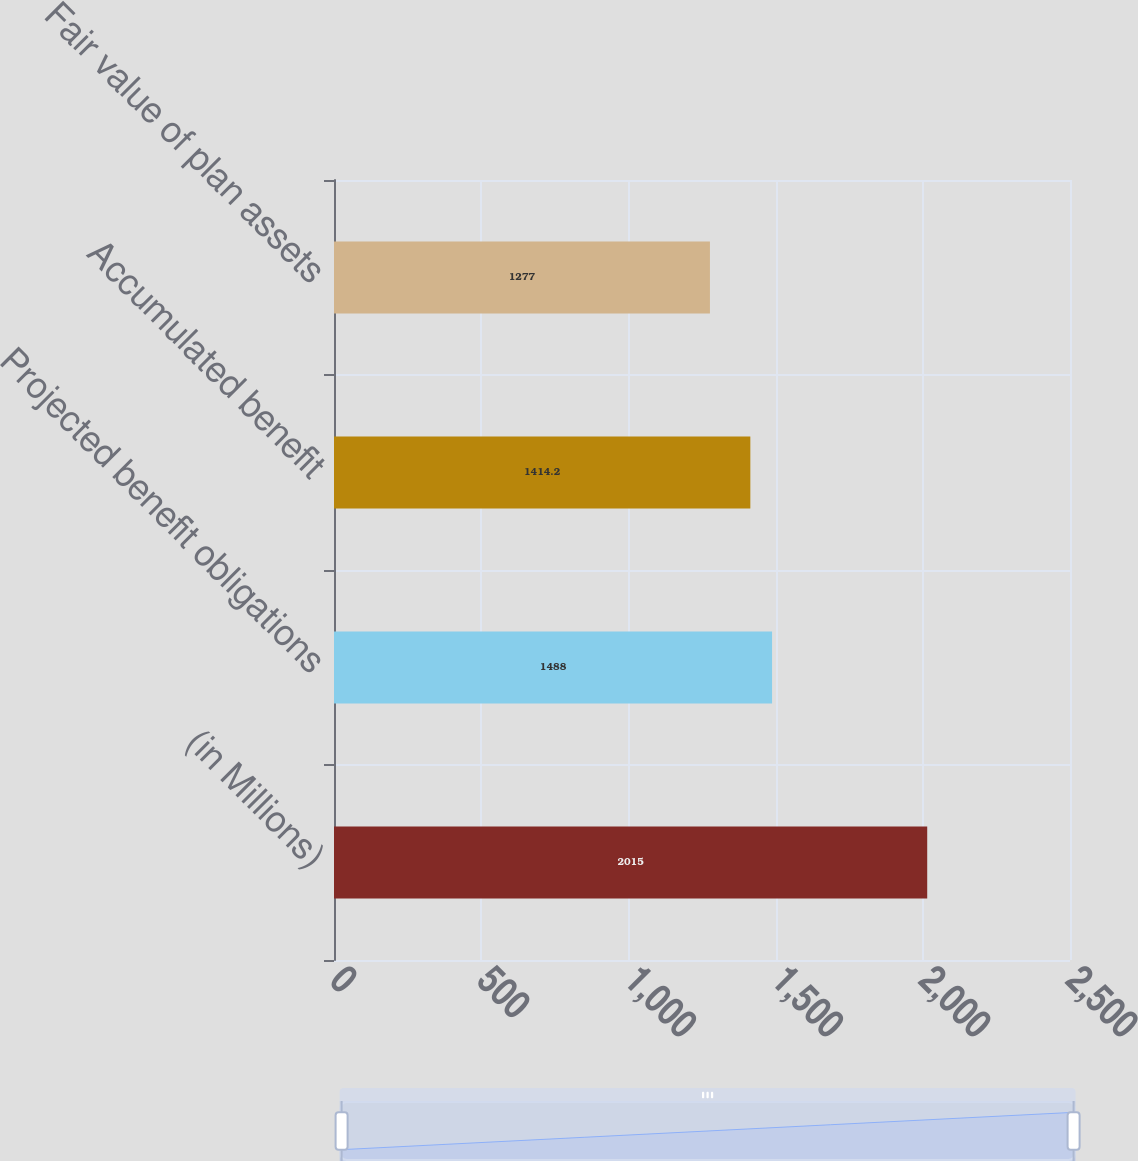Convert chart. <chart><loc_0><loc_0><loc_500><loc_500><bar_chart><fcel>(in Millions)<fcel>Projected benefit obligations<fcel>Accumulated benefit<fcel>Fair value of plan assets<nl><fcel>2015<fcel>1488<fcel>1414.2<fcel>1277<nl></chart> 